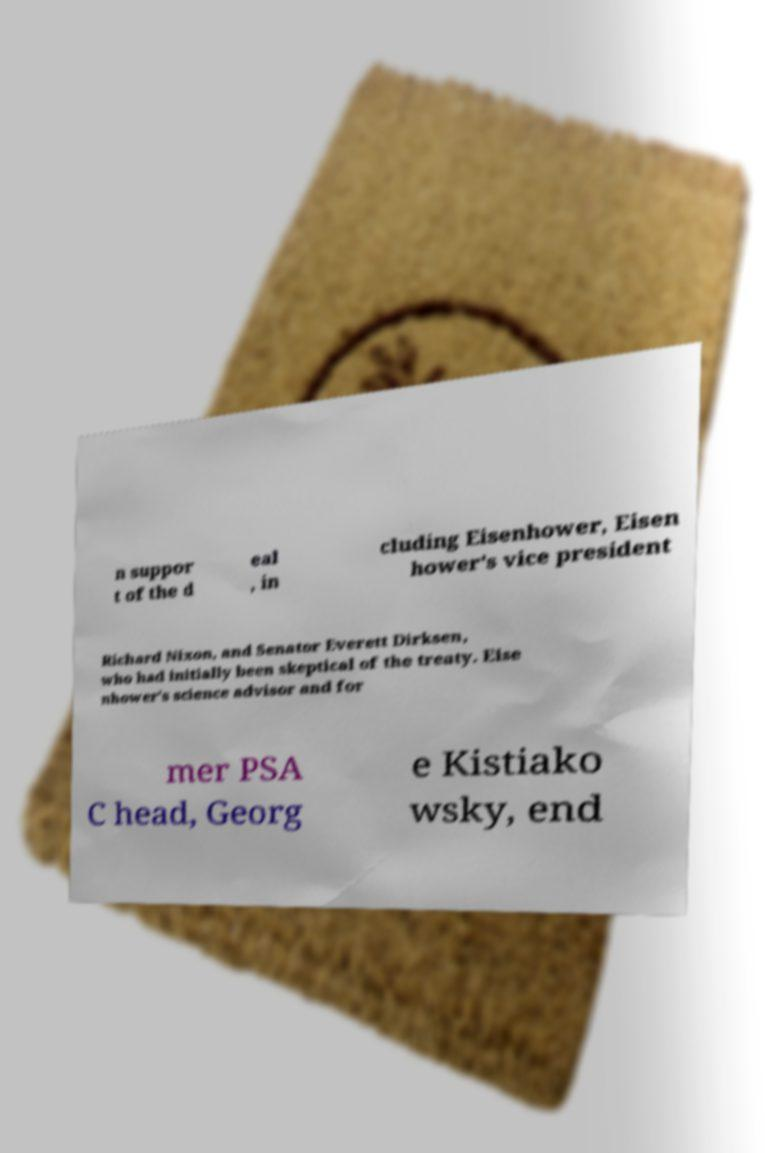Can you accurately transcribe the text from the provided image for me? n suppor t of the d eal , in cluding Eisenhower, Eisen hower's vice president Richard Nixon, and Senator Everett Dirksen, who had initially been skeptical of the treaty. Eise nhower's science advisor and for mer PSA C head, Georg e Kistiako wsky, end 